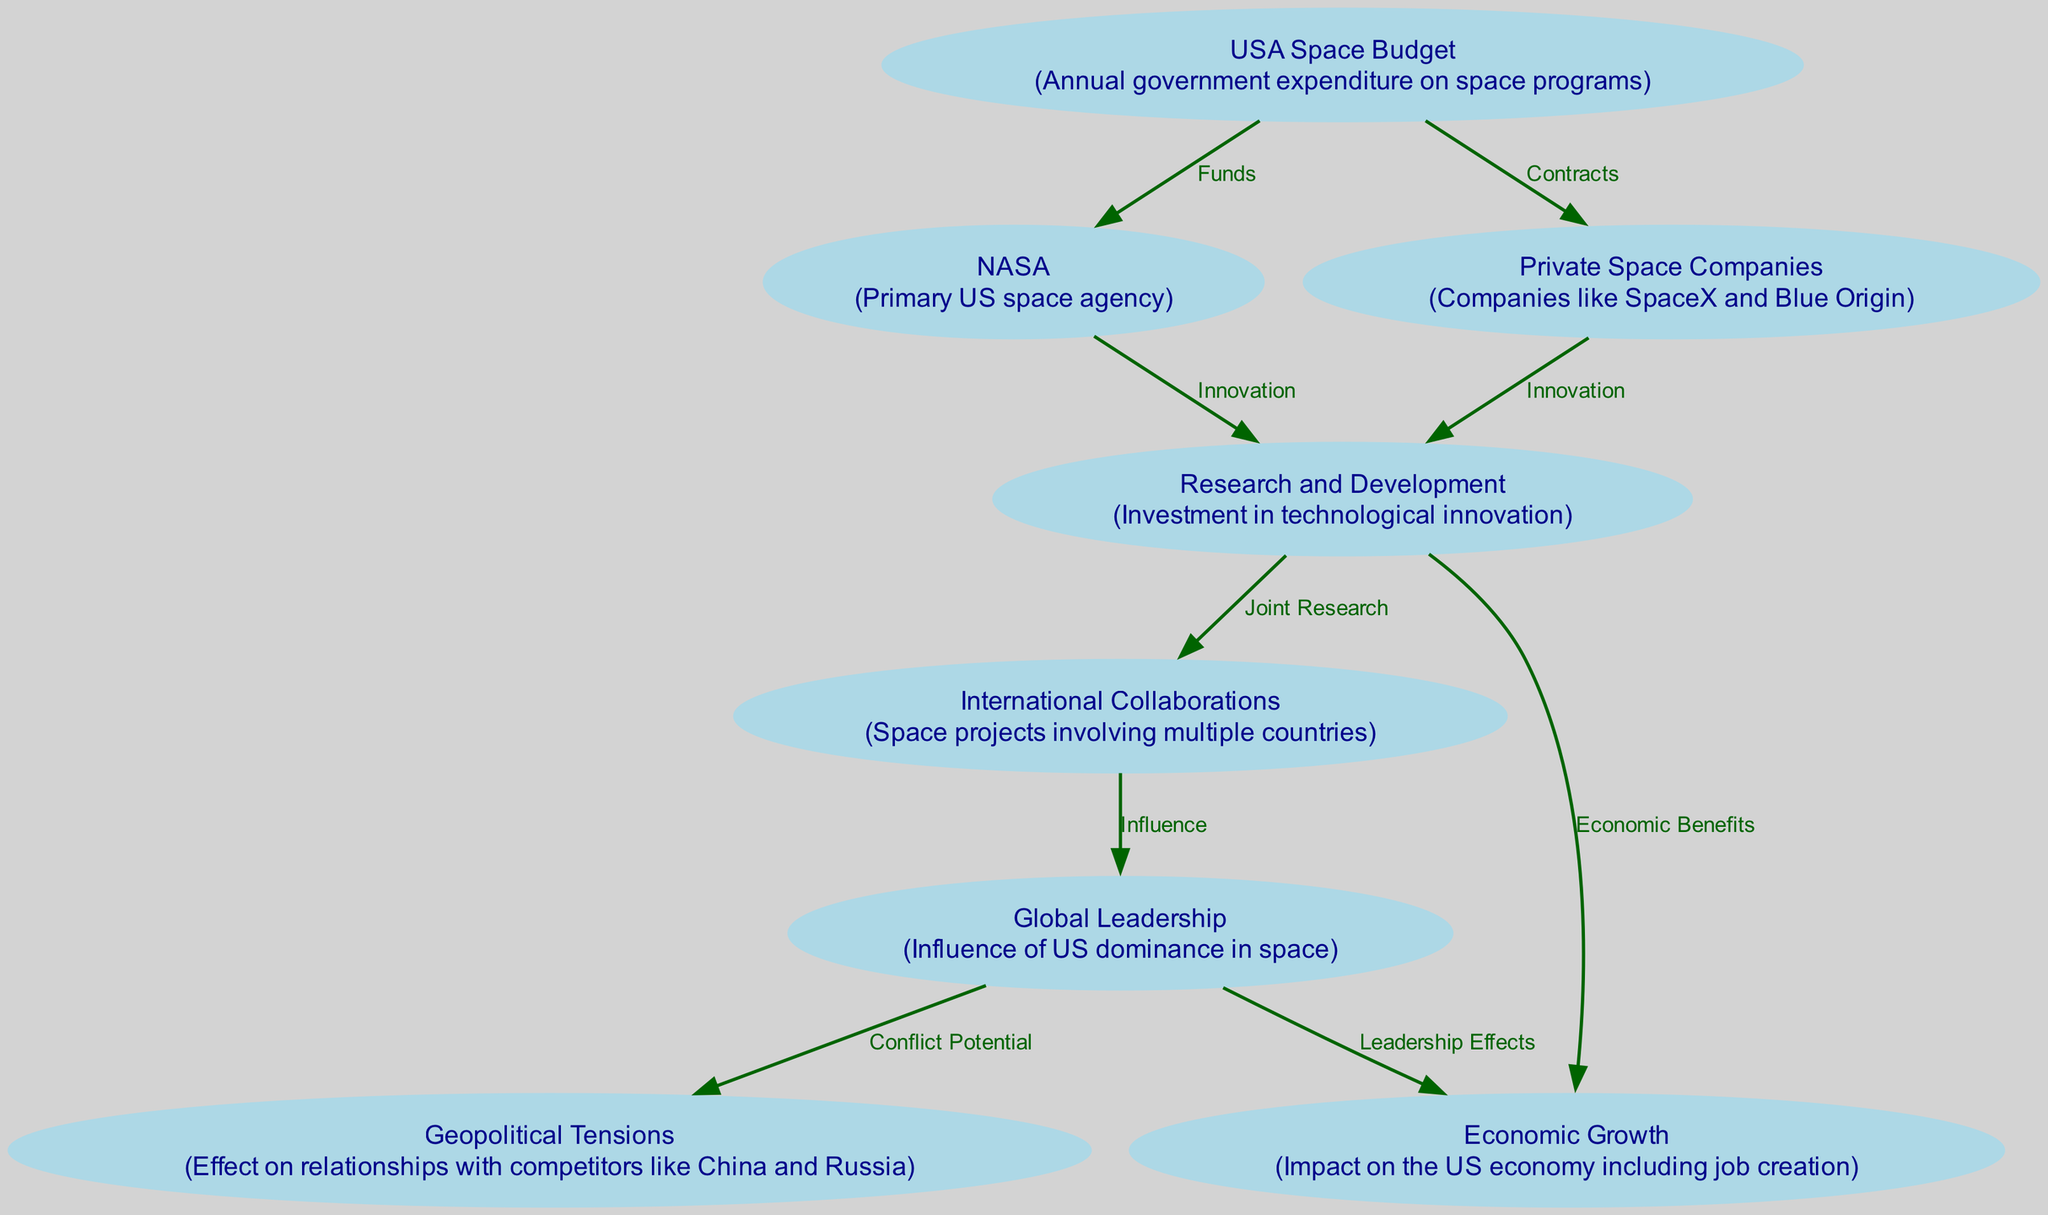What is the primary US space agency? The diagram labels "NASA" as the primary US space agency under the node for the USA Space Budget, indicating its role in space exploration funded by the US government.
Answer: NASA What links the USA Space Budget to Private Space Companies? The diagram shows a direct edge labeled "Contracts" connecting the USA Space Budget node to the Private Space Companies node, indicating that funds are allocated through contractual agreements to these companies.
Answer: Contracts How many nodes are present in the diagram? To find the number of nodes, we count the unique nodes listed, which are 8 in total.
Answer: 8 What are the effects of US global leadership on the economy? The diagram represents a connection labeled "Leadership Effects" from Global Leadership to Economic Growth, suggesting that the influence of US space dominance contributes positively to the economy.
Answer: Economic Benefits What is the relationship between Research and Development and International Collaborations? A directed edge exists connecting Research and Development to International Collaborations labeled "Joint Research", indicating that R&D efforts lead to collaborative international projects.
Answer: Joint Research What can potentially escalate geopolitical tensions according to the diagram? The arrows define that Geopolitical Tensions are influenced by the node Global Leadership, indicating that as the US asserts its space dominance, potential conflicts with rival nations may arise.
Answer: Conflict Potential How does NASA contribute to innovation? The diagram shows a connection stating "Innovation" between NASA and Research and Development, highlighting NASA's role in driving technological advancements through its activities.
Answer: Innovation What is one of the economic impacts of investment in Research and Development? The diagram reveals that the investment in Research and Development connects to Economic Growth with the label "Economic Benefits", suggesting a relationship where R&D funding leads to economic improvements.
Answer: Economic Benefits 